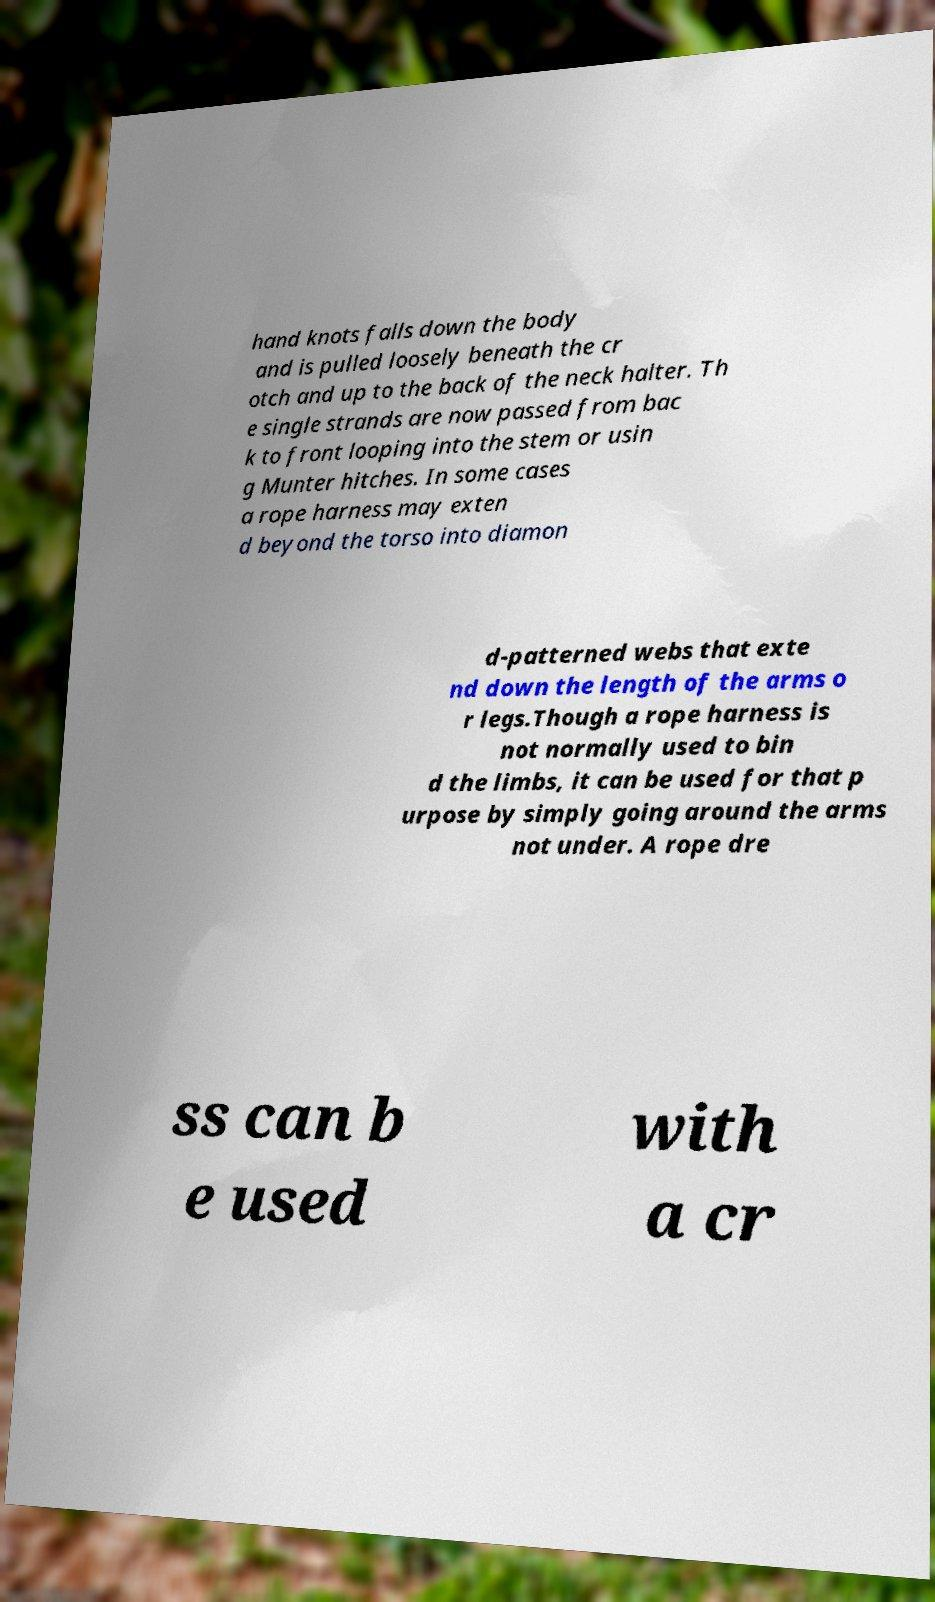Could you extract and type out the text from this image? hand knots falls down the body and is pulled loosely beneath the cr otch and up to the back of the neck halter. Th e single strands are now passed from bac k to front looping into the stem or usin g Munter hitches. In some cases a rope harness may exten d beyond the torso into diamon d-patterned webs that exte nd down the length of the arms o r legs.Though a rope harness is not normally used to bin d the limbs, it can be used for that p urpose by simply going around the arms not under. A rope dre ss can b e used with a cr 